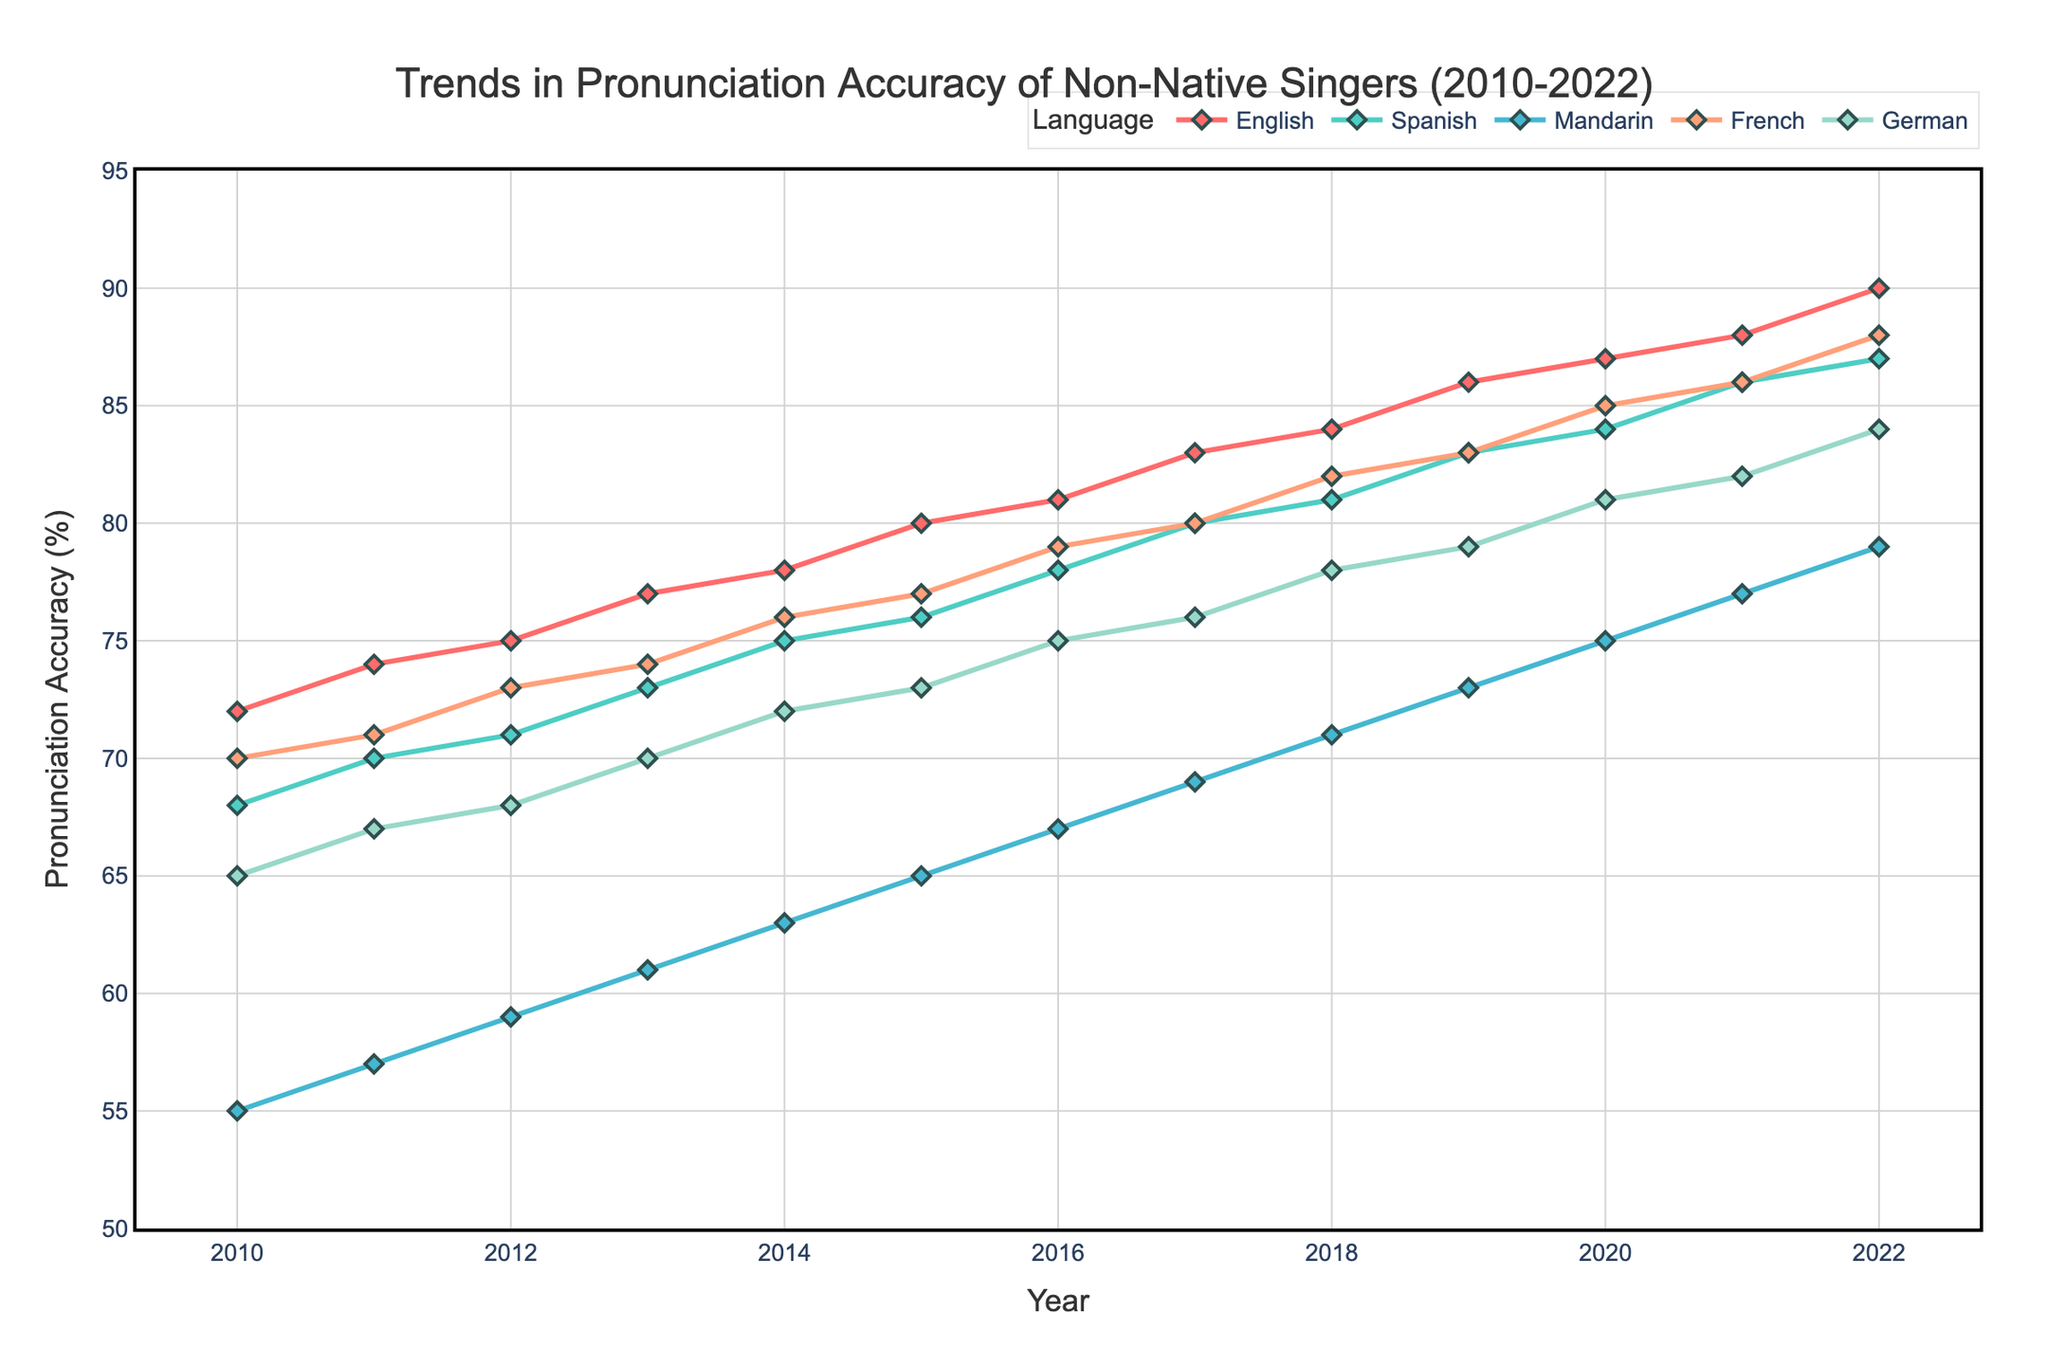What is the trend in pronunciation accuracy for Mandarin from 2010 to 2022? Observing the graph, the pronunciation accuracy for Mandarin shows a consistent upward trend from 2010 (55%) to 2022 (79%).
Answer: Consistent upward trend Which language had the highest pronunciation accuracy in 2022? At the year 2022, the highest point on the graph corresponds to English, where the pronunciation accuracy is 90%.
Answer: English By how many percentage points did the pronunciation accuracy in Spanish increase from 2010 to 2015? In 2010, the accuracy for Spanish was 68%. In 2015, it was 76%. The increase can be calculated as 76% - 68% = 8 percentage points.
Answer: 8 percentage points Which language showed the most significant improvement in pronunciation accuracy over the entire period? Calculating the improvement from 2010 to 2022 for each language and comparing these: English increased from 72% to 90% (18%), Spanish from 68% to 87% (19%), Mandarin from 55% to 79% (24%), French from 70% to 88% (18%), German from 65% to 84% (19%). Mandarin shows the greatest improvement with a 24% increase.
Answer: Mandarin Compare the pronunciation accuracy for English and French in 2013. Which was higher? In 2013, the pronunciation accuracy for English was 77%, while for French it was 74%. Therefore, English had a higher pronunciation accuracy than French in 2013.
Answer: English Which language showed the least variation in pronunciation accuracy over the period? To determine the least variation, we can look at the range of accuracy percentages for each language. English: 72-90 (18%), Spanish: 68-87 (19%), Mandarin: 55-79 (24%), French: 70-88 (18%), German: 65-84 (19%). Both English and French showed a variation of 18%, which is the lowest.
Answer: English and French On average, how much did the pronunciation accuracy for German improve each year between 2010 and 2022? The total improvement for German from 2010 (65%) to 2022 (84%) is 84% - 65% = 19 percentage points. There are 12 years between 2010 and 2022 inclusive. So, the average annual improvement is 19/12 ≈ 1.58 percentage points per year.
Answer: About 1.58 percentage points per year Between which years did Mandarin experience the largest yearly increase in pronunciation accuracy? Observing year-over-year increases for Mandarin, the largest increase is from 2015 (65%) to 2016 (67%) = 2 percentage points.
Answer: 2015 to 2016 How do the pronunciation accuracy trends of Spanish and German compare over the given years? Both Spanish and German show a consistent upward trend in pronunciation accuracy from 2010 to 2022. While Spanish starts at a higher accuracy of 68% versus German's 65%, both end close to each other by 2022: Spanish at 87% and German at 84%.
Answer: Similar upward trends 